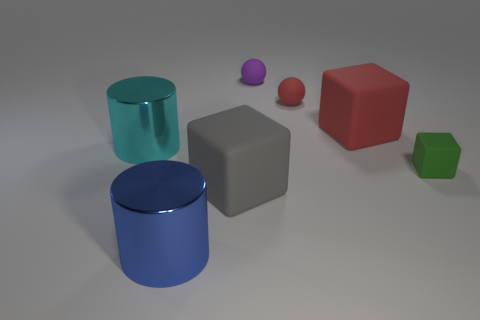Is there anything else that is the same material as the green object?
Your answer should be compact. Yes. There is another large thing that is the same shape as the big cyan metal thing; what is its material?
Ensure brevity in your answer.  Metal. What number of matte objects are either small green cubes or big gray objects?
Give a very brief answer. 2. Are the cylinder that is on the left side of the blue metal cylinder and the large cube in front of the green cube made of the same material?
Ensure brevity in your answer.  No. Is there a small purple metallic block?
Provide a short and direct response. No. There is a tiny purple thing that is behind the green cube; is it the same shape as the small rubber object in front of the big cyan cylinder?
Provide a succinct answer. No. Are there any other cylinders made of the same material as the cyan cylinder?
Offer a very short reply. Yes. Are the big cube that is to the left of the purple matte thing and the tiny block made of the same material?
Offer a terse response. Yes. Is the number of red spheres to the left of the large cyan cylinder greater than the number of cyan metallic things that are behind the purple matte ball?
Make the answer very short. No. What color is the matte sphere that is the same size as the purple object?
Offer a terse response. Red. 